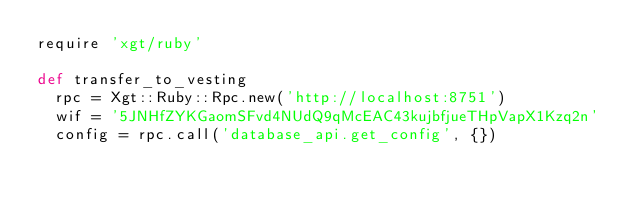Convert code to text. <code><loc_0><loc_0><loc_500><loc_500><_Ruby_>require 'xgt/ruby'

def transfer_to_vesting  
  rpc = Xgt::Ruby::Rpc.new('http://localhost:8751')
  wif = '5JNHfZYKGaomSFvd4NUdQ9qMcEAC43kujbfjueTHpVapX1Kzq2n'
  config = rpc.call('database_api.get_config', {})</code> 